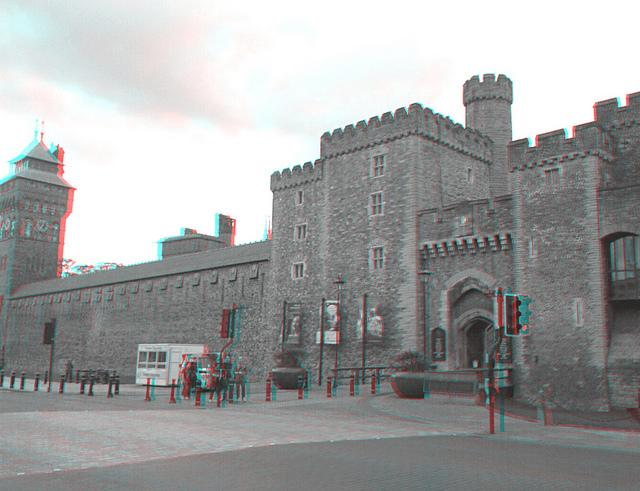What instance of building is shown in the image? castle 